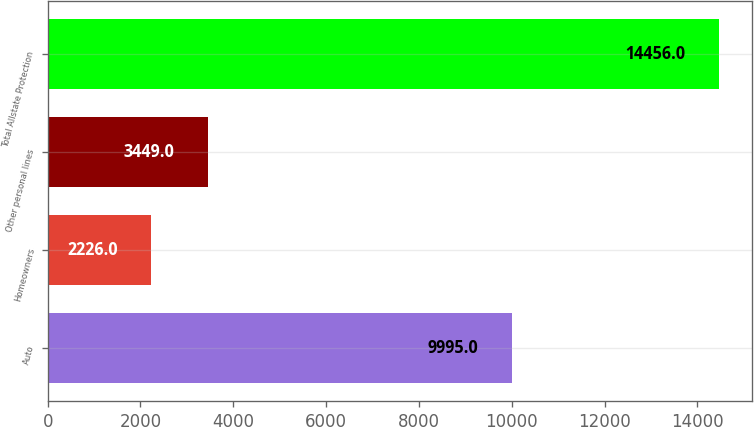<chart> <loc_0><loc_0><loc_500><loc_500><bar_chart><fcel>Auto<fcel>Homeowners<fcel>Other personal lines<fcel>Total Allstate Protection<nl><fcel>9995<fcel>2226<fcel>3449<fcel>14456<nl></chart> 